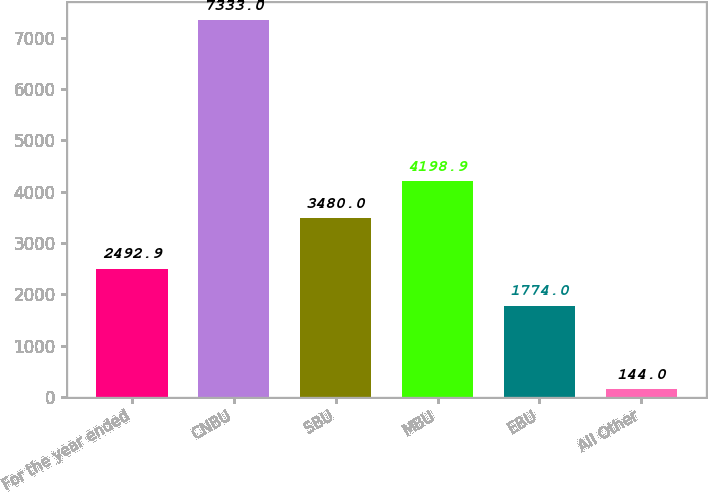<chart> <loc_0><loc_0><loc_500><loc_500><bar_chart><fcel>For the year ended<fcel>CNBU<fcel>SBU<fcel>MBU<fcel>EBU<fcel>All Other<nl><fcel>2492.9<fcel>7333<fcel>3480<fcel>4198.9<fcel>1774<fcel>144<nl></chart> 